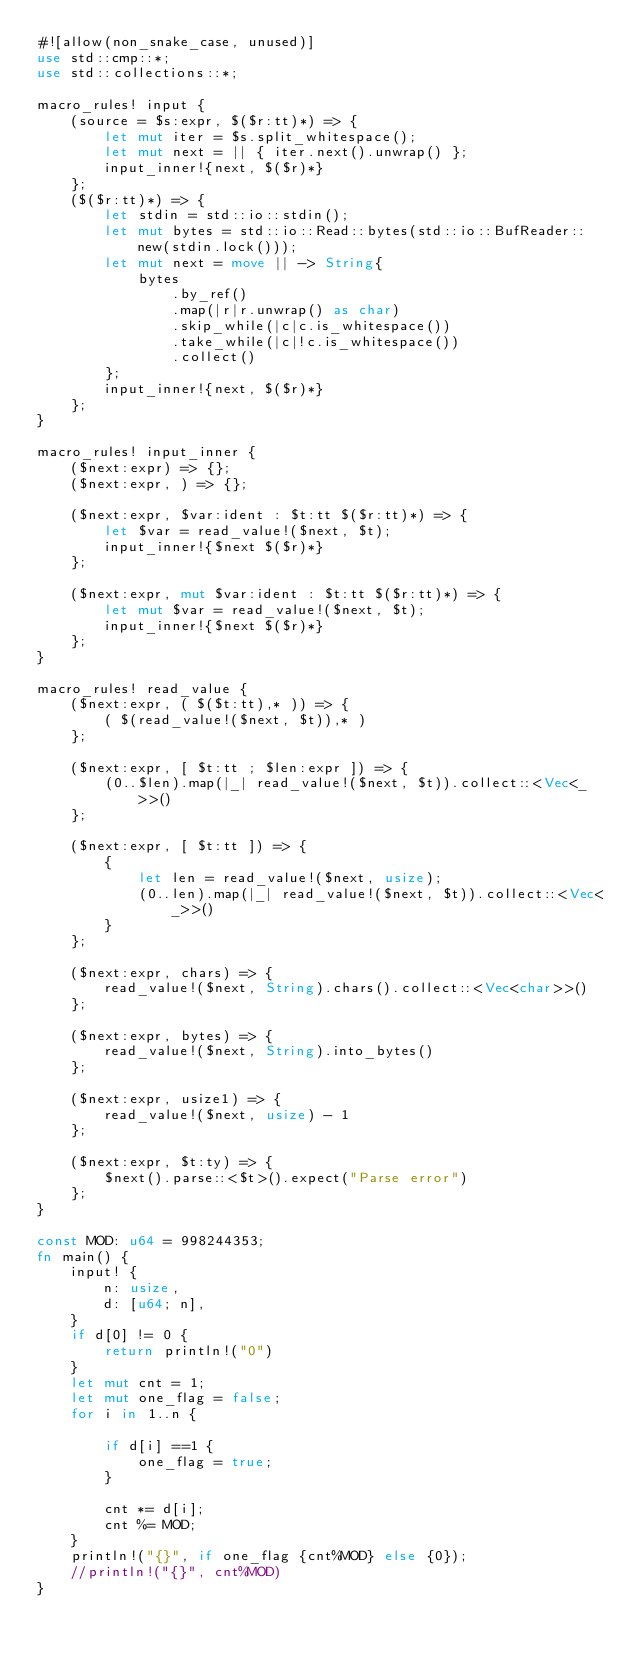<code> <loc_0><loc_0><loc_500><loc_500><_Rust_>#![allow(non_snake_case, unused)]
use std::cmp::*;
use std::collections::*;

macro_rules! input {
    (source = $s:expr, $($r:tt)*) => {
        let mut iter = $s.split_whitespace();
        let mut next = || { iter.next().unwrap() };
        input_inner!{next, $($r)*}
    };
    ($($r:tt)*) => {
        let stdin = std::io::stdin();
        let mut bytes = std::io::Read::bytes(std::io::BufReader::new(stdin.lock()));
        let mut next = move || -> String{
            bytes
                .by_ref()
                .map(|r|r.unwrap() as char)
                .skip_while(|c|c.is_whitespace())
                .take_while(|c|!c.is_whitespace())
                .collect()
        };
        input_inner!{next, $($r)*}
    };
}

macro_rules! input_inner {
    ($next:expr) => {};
    ($next:expr, ) => {};

    ($next:expr, $var:ident : $t:tt $($r:tt)*) => {
        let $var = read_value!($next, $t);
        input_inner!{$next $($r)*}
    };

    ($next:expr, mut $var:ident : $t:tt $($r:tt)*) => {
        let mut $var = read_value!($next, $t);
        input_inner!{$next $($r)*}
    };
}

macro_rules! read_value {
    ($next:expr, ( $($t:tt),* )) => {
        ( $(read_value!($next, $t)),* )
    };

    ($next:expr, [ $t:tt ; $len:expr ]) => {
        (0..$len).map(|_| read_value!($next, $t)).collect::<Vec<_>>()
    };

    ($next:expr, [ $t:tt ]) => {
        {
            let len = read_value!($next, usize);
            (0..len).map(|_| read_value!($next, $t)).collect::<Vec<_>>()
        }
    };

    ($next:expr, chars) => {
        read_value!($next, String).chars().collect::<Vec<char>>()
    };

    ($next:expr, bytes) => {
        read_value!($next, String).into_bytes()
    };

    ($next:expr, usize1) => {
        read_value!($next, usize) - 1
    };

    ($next:expr, $t:ty) => {
        $next().parse::<$t>().expect("Parse error")
    };
}

const MOD: u64 = 998244353;
fn main() {
    input! {
        n: usize,
        d: [u64; n],
    }
    if d[0] != 0 {
        return println!("0")
    }
    let mut cnt = 1;
    let mut one_flag = false;
    for i in 1..n {
        
        if d[i] ==1 {
            one_flag = true;
        }
        
        cnt *= d[i];
        cnt %= MOD;
    }
    println!("{}", if one_flag {cnt%MOD} else {0});
    //println!("{}", cnt%MOD)
}
</code> 